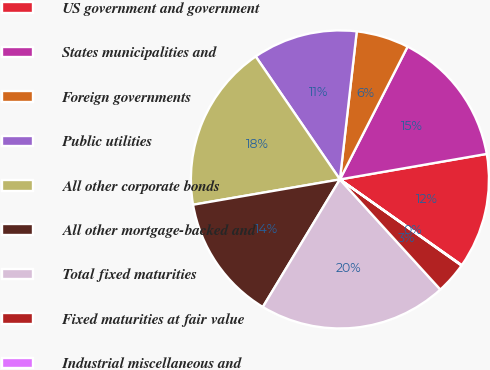<chart> <loc_0><loc_0><loc_500><loc_500><pie_chart><fcel>US government and government<fcel>States municipalities and<fcel>Foreign governments<fcel>Public utilities<fcel>All other corporate bonds<fcel>All other mortgage-backed and<fcel>Total fixed maturities<fcel>Fixed maturities at fair value<fcel>Industrial miscellaneous and<nl><fcel>12.5%<fcel>14.76%<fcel>5.7%<fcel>11.36%<fcel>18.16%<fcel>13.63%<fcel>20.42%<fcel>3.43%<fcel>0.04%<nl></chart> 